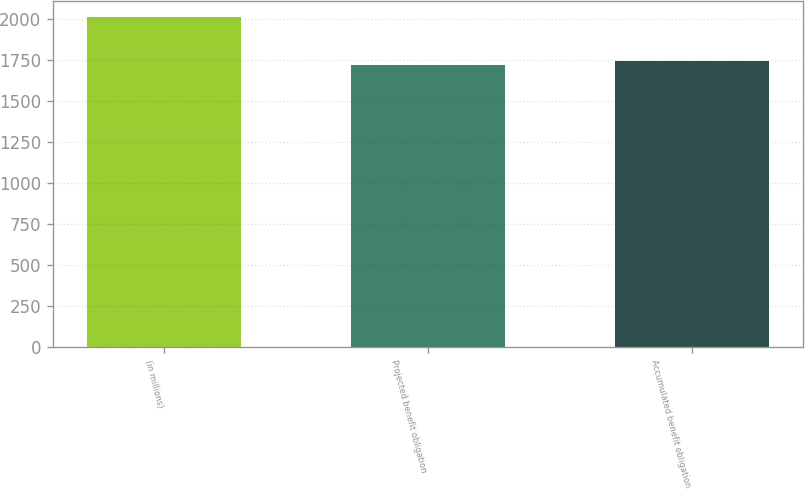Convert chart. <chart><loc_0><loc_0><loc_500><loc_500><bar_chart><fcel>(in millions)<fcel>Projected benefit obligation<fcel>Accumulated benefit obligation<nl><fcel>2010<fcel>1716<fcel>1745.4<nl></chart> 